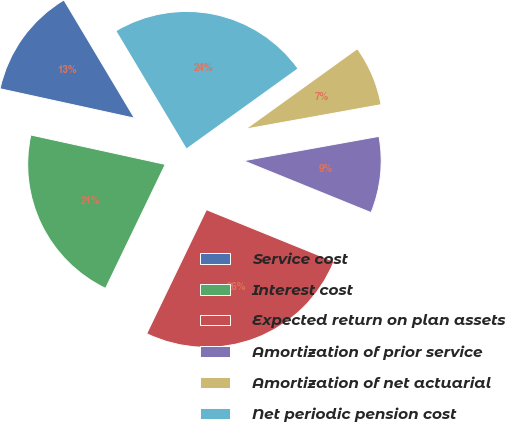<chart> <loc_0><loc_0><loc_500><loc_500><pie_chart><fcel>Service cost<fcel>Interest cost<fcel>Expected return on plan assets<fcel>Amortization of prior service<fcel>Amortization of net actuarial<fcel>Net periodic pension cost<nl><fcel>13.0%<fcel>21.28%<fcel>26.0%<fcel>8.98%<fcel>7.09%<fcel>23.64%<nl></chart> 